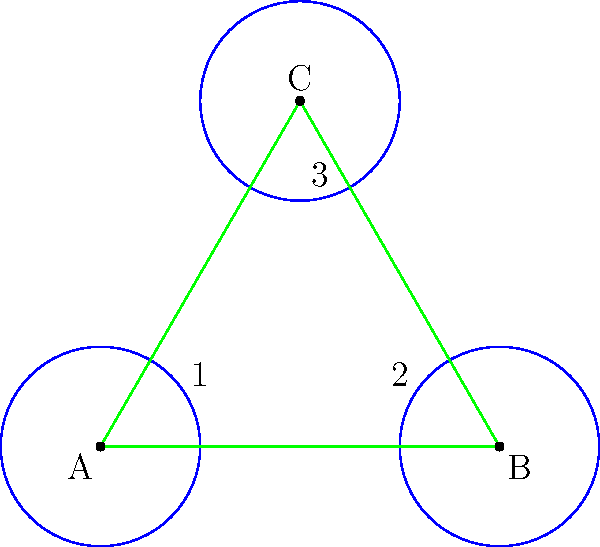In designing a symmetrical garnish pattern for a gourmet dish, you've arranged three circles to form an equilateral triangle. If the circles are congruent and their centers form an equilateral triangle with side length 4 units, what is the radius of each circle? To solve this problem, let's follow these steps:

1) First, recall that in an equilateral triangle, all sides are equal and all angles are 60°.

2) The centers of the circles form an equilateral triangle with side length 4 units.

3) In an equilateral triangle, the altitude (height) can be calculated using the formula:
   $h = \frac{\sqrt{3}}{2} * side$

4) In this case, $h = \frac{\sqrt{3}}{2} * 4 = 2\sqrt{3}$

5) Now, consider one of the sides of the triangle. The two circles at the ends of this side are touching each other and the side of the triangle.

6) If we draw a line from the center of one circle to the point where it touches the other circle, this line will be perpendicular to the side of the triangle and will have a length equal to the radius of the circle.

7) This creates a right triangle, where:
   - The hypotenuse is the side of the equilateral triangle (4 units)
   - One leg is the sum of the radii of two circles (2r)
   - The other leg is the radius of one circle (r)

8) We can use the Pythagorean theorem:
   $4^2 = (2r)^2 + r^2$

9) Simplify:
   $16 = 4r^2 + r^2 = 5r^2$

10) Solve for r:
    $r^2 = \frac{16}{5}$
    $r = \frac{4}{\sqrt{5}}$

Therefore, the radius of each circle is $\frac{4}{\sqrt{5}}$ units.
Answer: $\frac{4}{\sqrt{5}}$ units 